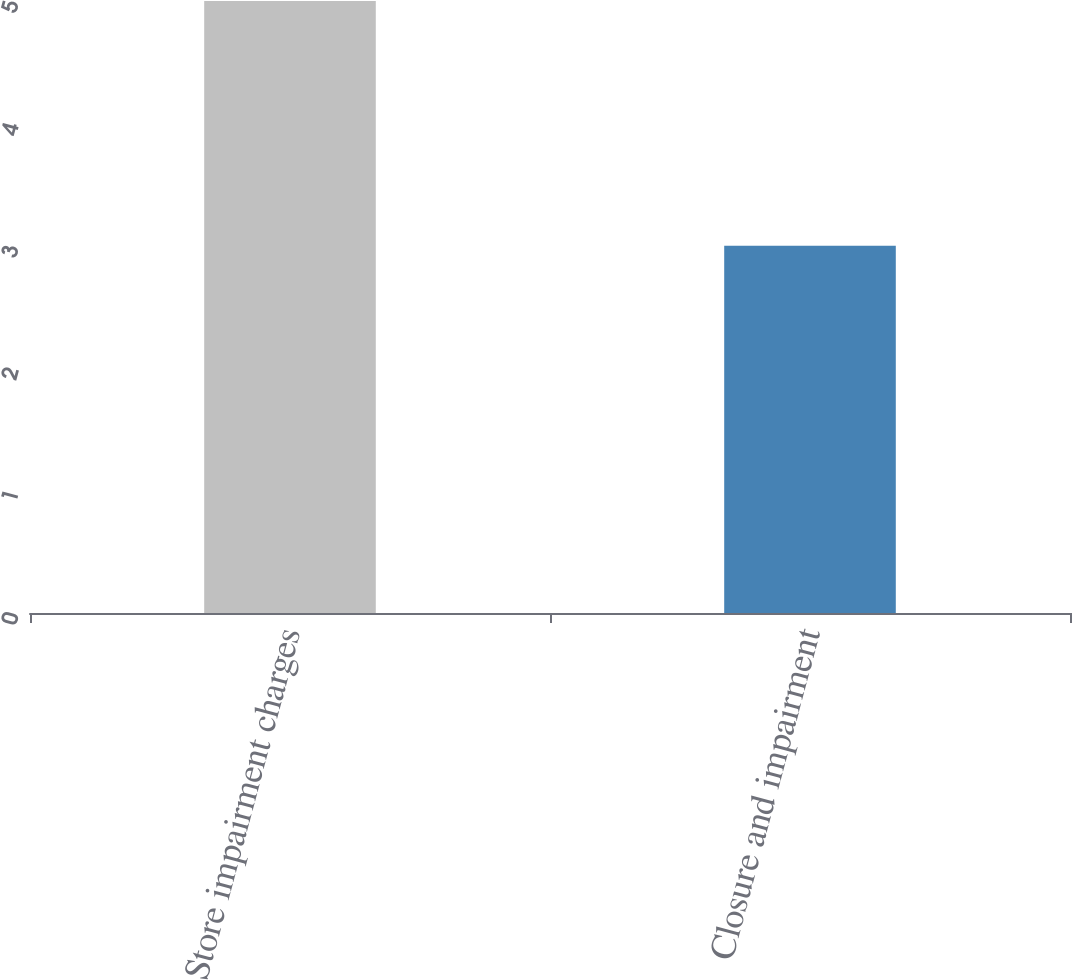Convert chart. <chart><loc_0><loc_0><loc_500><loc_500><bar_chart><fcel>Store impairment charges<fcel>Closure and impairment<nl><fcel>5<fcel>3<nl></chart> 